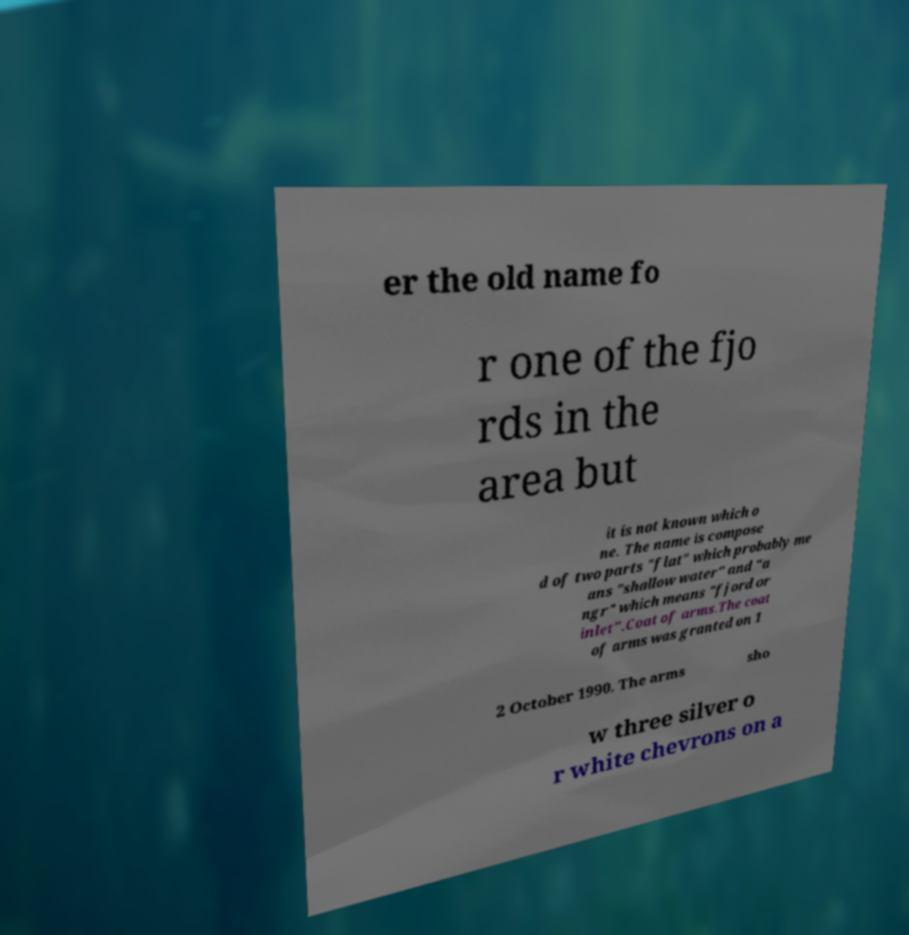For documentation purposes, I need the text within this image transcribed. Could you provide that? er the old name fo r one of the fjo rds in the area but it is not known which o ne. The name is compose d of two parts "flat" which probably me ans "shallow water" and "a ngr" which means "fjord or inlet".Coat of arms.The coat of arms was granted on 1 2 October 1990. The arms sho w three silver o r white chevrons on a 